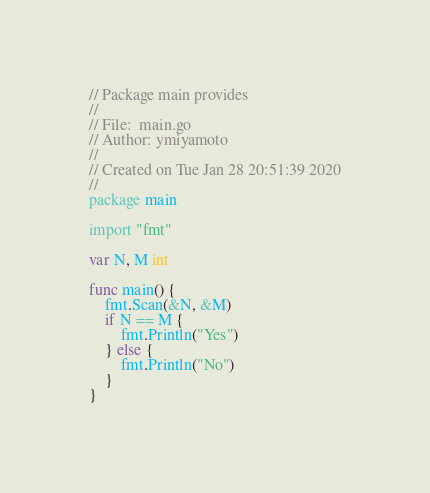<code> <loc_0><loc_0><loc_500><loc_500><_Go_>// Package main provides
//
// File:  main.go
// Author: ymiyamoto
//
// Created on Tue Jan 28 20:51:39 2020
//
package main

import "fmt"

var N, M int

func main() {
	fmt.Scan(&N, &M)
	if N == M {
		fmt.Println("Yes")
	} else {
		fmt.Println("No")
	}
}
</code> 